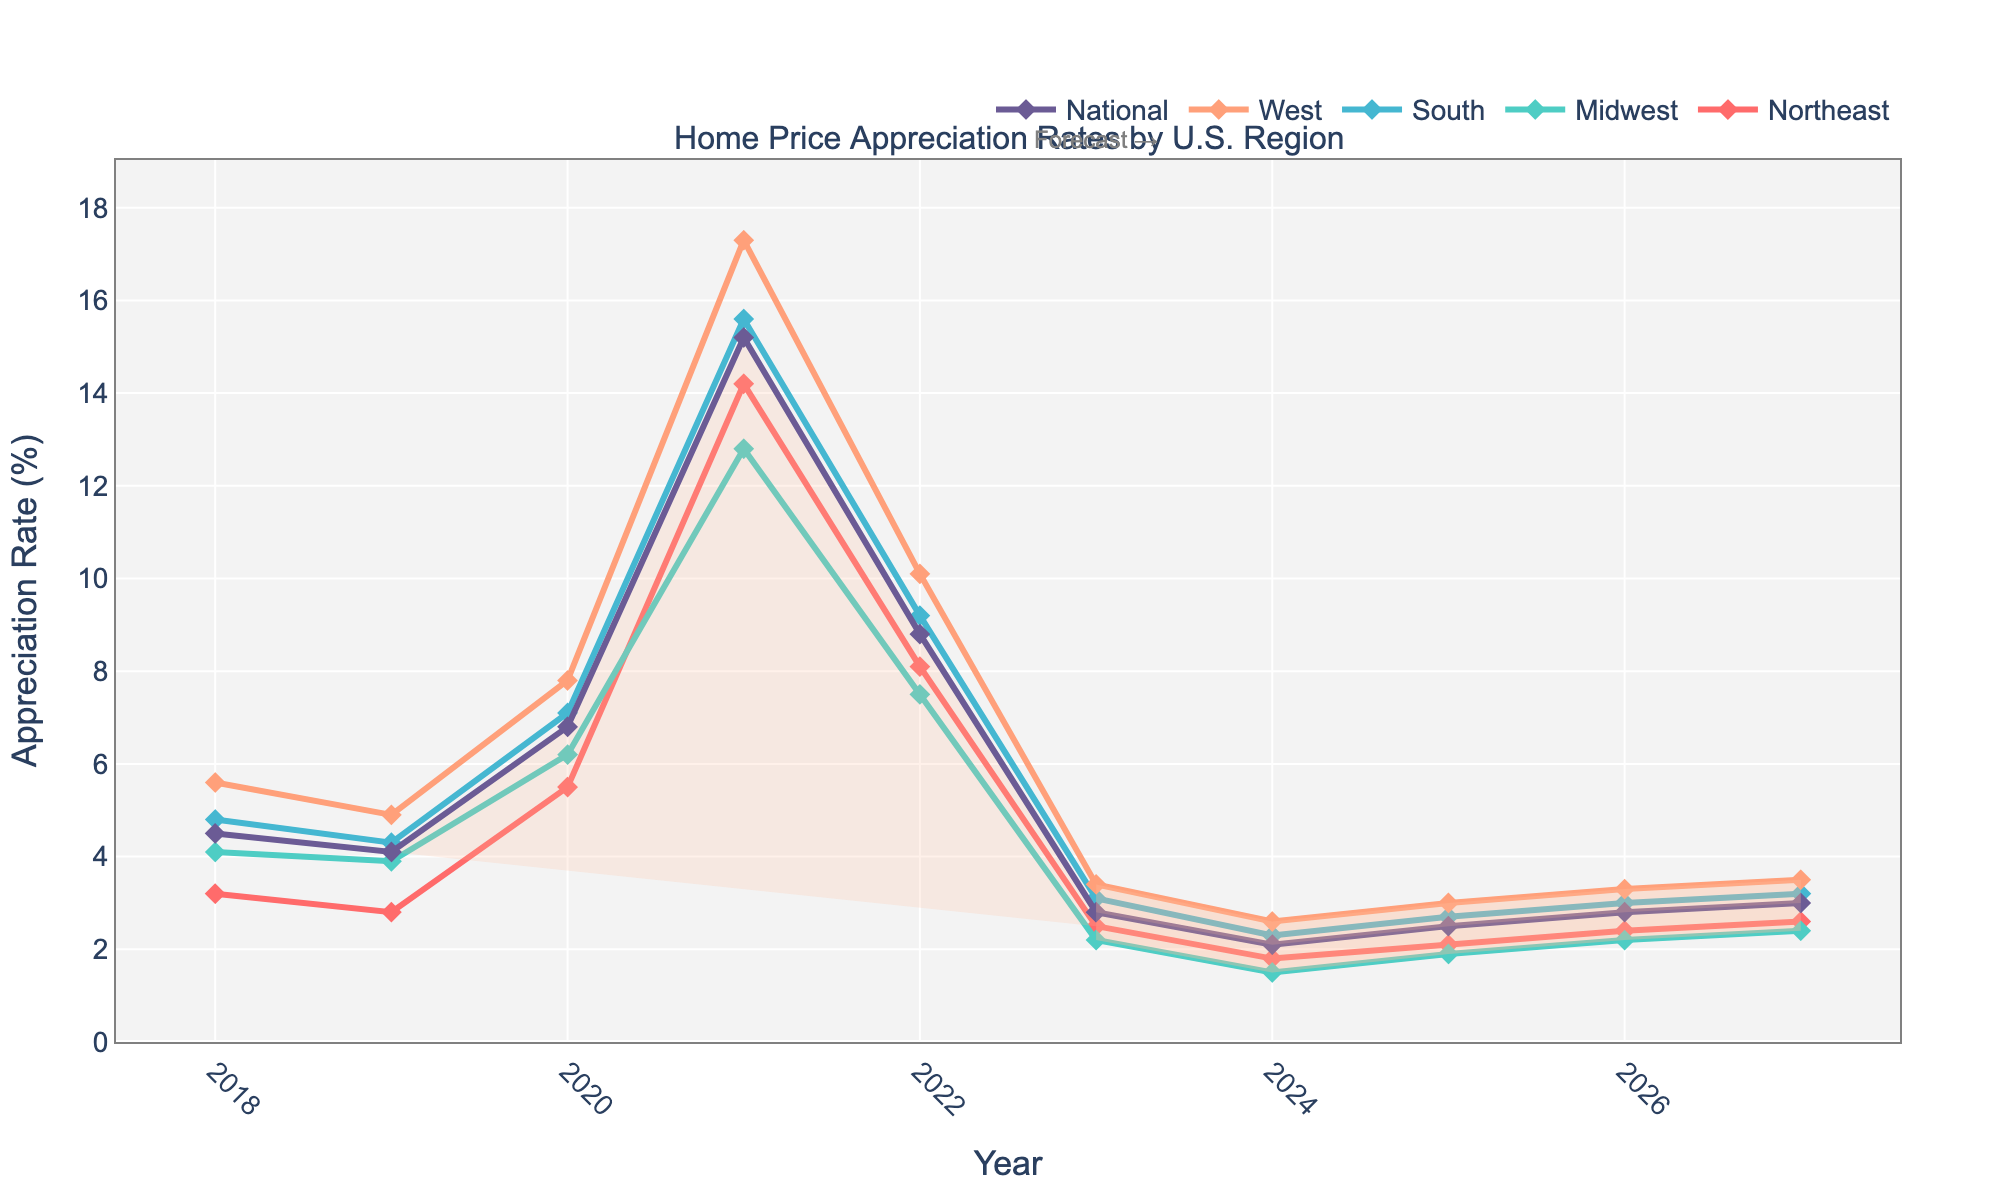What's the title of the plot? The title of the plot is stated at the top and it reads "Home Price Appreciation Rates by U.S. Region".
Answer: Home Price Appreciation Rates by U.S. Region Which region had the highest appreciation rate in 2021? By looking at the year 2021 on the x-axis and comparing the lines, the West region had the highest appreciation rate.
Answer: West In which year did the National appreciation rate peak? The highest point of the National line on the y-axis corresponds with the year 2021 on the x-axis.
Answer: 2021 What noticeable trend starts from the year 2023? From 2023 onwards, there is a shaded area in each region's line, indicating the forecasted data.
Answer: Forecast shaded area starts Compare the appreciation rate trends between the Northeast and the South from 2018 to 2023. From 2018 to 2021, the South consistently had higher appreciation rates than the Northeast. Both regions peak in 2021, and from 2022 onwards, both regions show a declining trend.
Answer: South had higher rates, both peaked in 2021, then declined Which region's appreciation rate dipped the lowest in 2023? Looking at the year 2023 on the x-axis and the corresponding y-values, the Midwest region has the lowest appreciation rate.
Answer: Midwest Between 2023 and 2027, which region is projected to have the highest average appreciation rate? To find the highest average, we look at the shaded forecasted area for each region from 2023 to 2027 and compare the midpoints. The West region appears to have the highest average rates.
Answer: West How does the appreciation rate for the National level in 2027 compare with 2018? The National appreciation rate in 2018 is around 4.5% while in 2027, it is approximately 3%.
Answer: Lower in 2027 What is the trend of the Midwest appreciation rate from 2022 to 2027? Starting from 2022, the Midwest rate decreases and then slightly increases in the following years up to 2027.
Answer: Decrease then slight increase What is the color used to represent the South region in the plot? The South region is represented by the color that corresponds to its line; it is a shade of blue.
Answer: Blue 